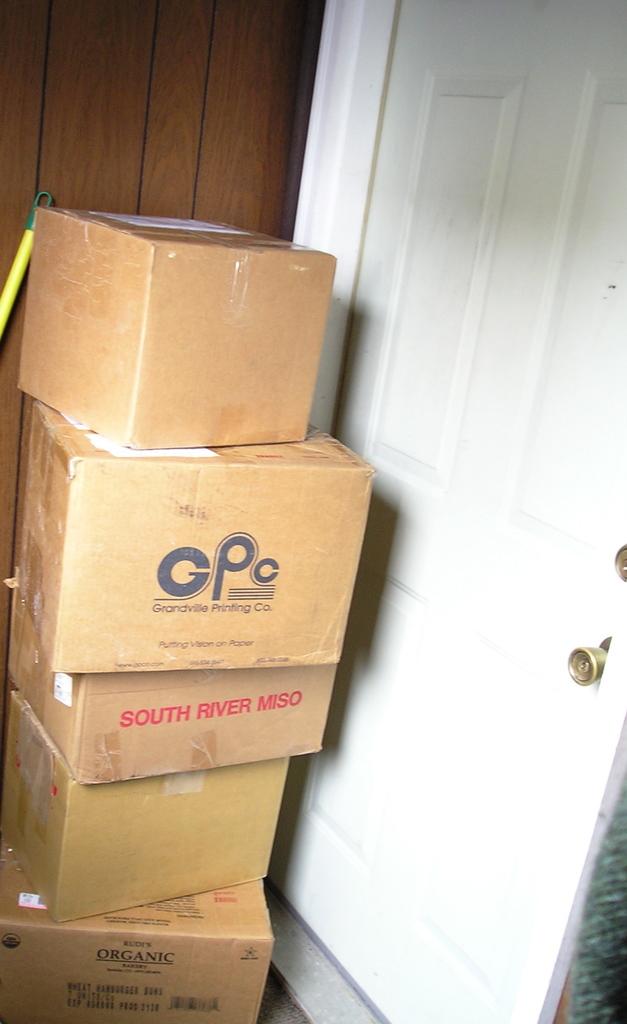What does the box with red text say?
Your answer should be very brief. South river miso. What are the big black letters on the second box?
Your answer should be compact. Gpc. 